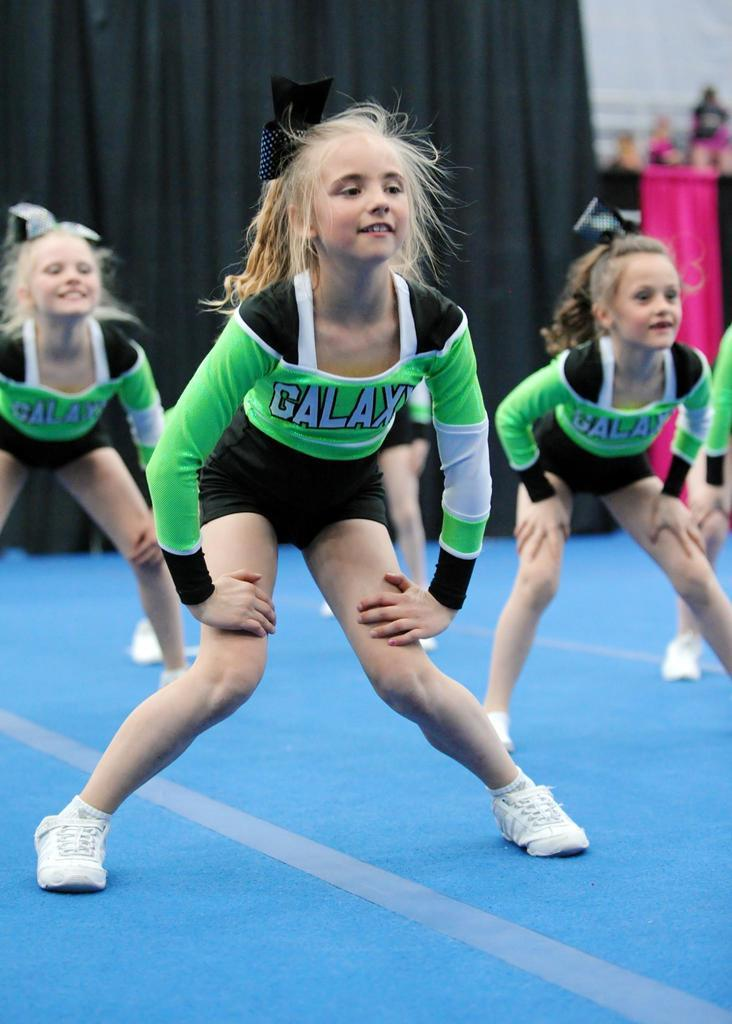<image>
Relay a brief, clear account of the picture shown. Several young girls in Galaxy uniforms do exercises. 